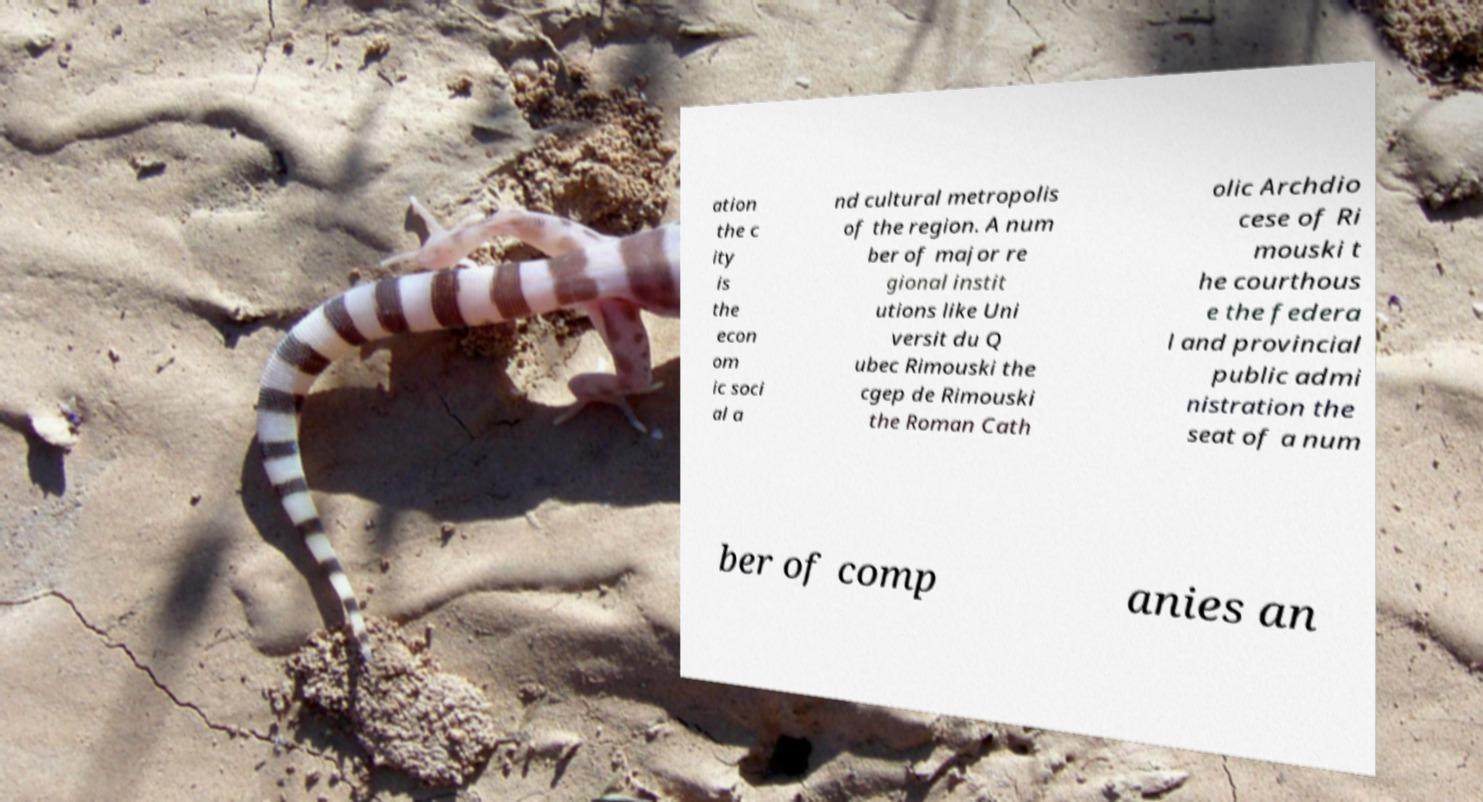Please identify and transcribe the text found in this image. ation the c ity is the econ om ic soci al a nd cultural metropolis of the region. A num ber of major re gional instit utions like Uni versit du Q ubec Rimouski the cgep de Rimouski the Roman Cath olic Archdio cese of Ri mouski t he courthous e the federa l and provincial public admi nistration the seat of a num ber of comp anies an 